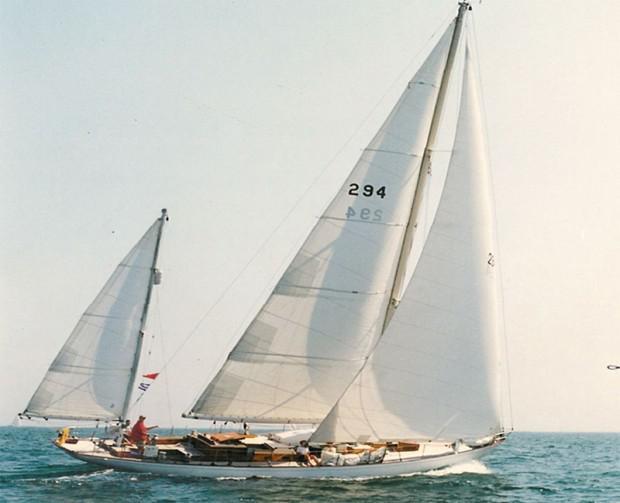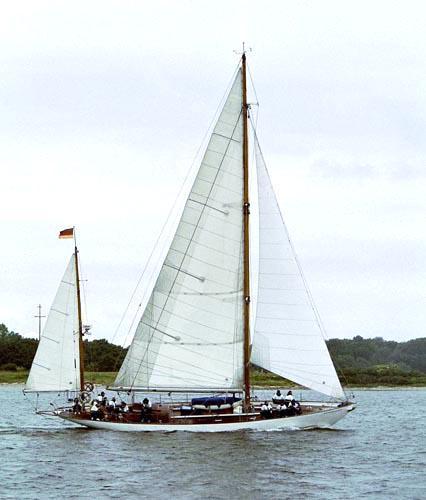The first image is the image on the left, the second image is the image on the right. Evaluate the accuracy of this statement regarding the images: "Trees can be seen in the background in one  of the images.". Is it true? Answer yes or no. Yes. The first image is the image on the left, the second image is the image on the right. Assess this claim about the two images: "there are puffy clouds in one of the images". Correct or not? Answer yes or no. No. 